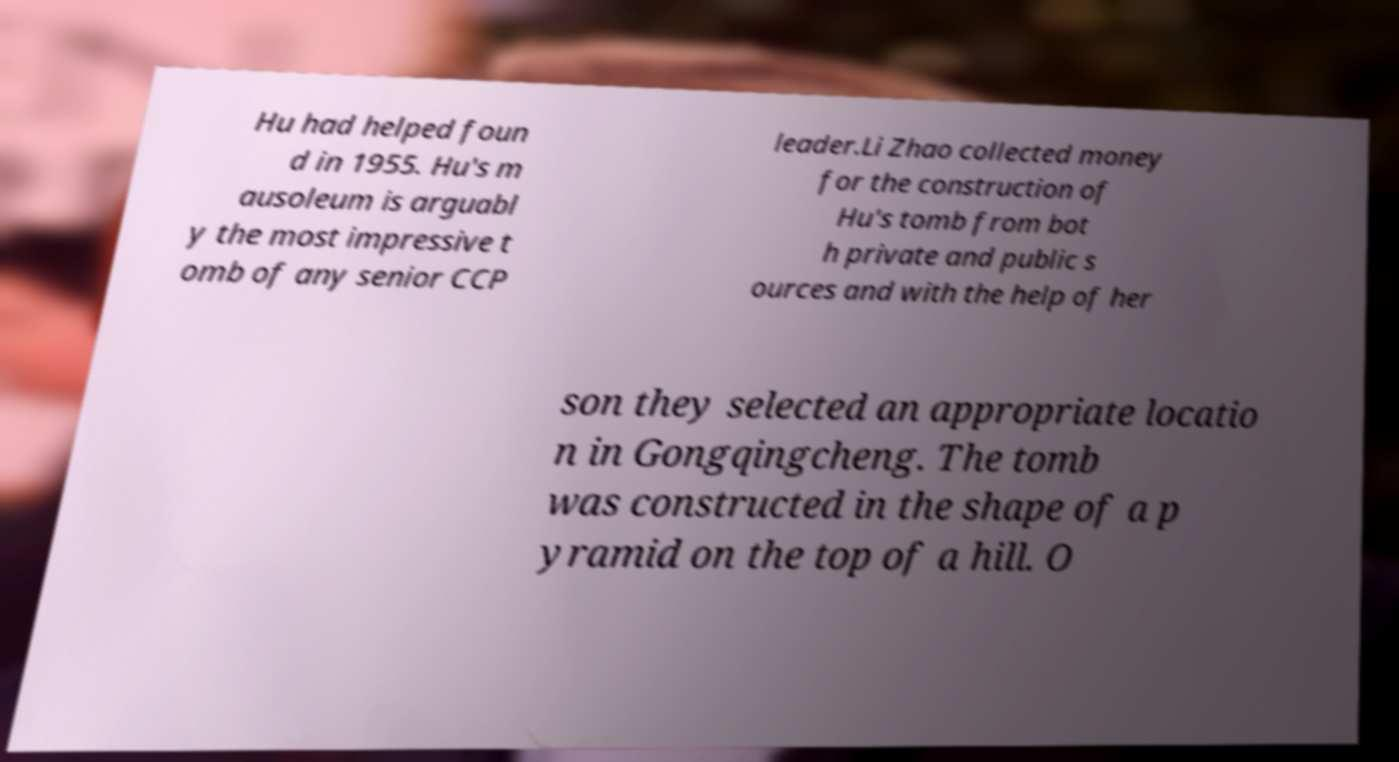There's text embedded in this image that I need extracted. Can you transcribe it verbatim? Hu had helped foun d in 1955. Hu's m ausoleum is arguabl y the most impressive t omb of any senior CCP leader.Li Zhao collected money for the construction of Hu's tomb from bot h private and public s ources and with the help of her son they selected an appropriate locatio n in Gongqingcheng. The tomb was constructed in the shape of a p yramid on the top of a hill. O 